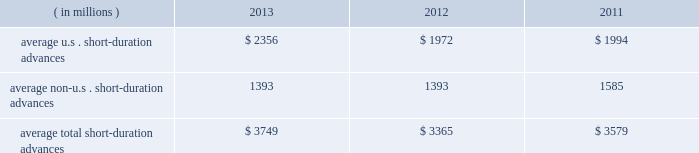Management 2019s discussion and analysis of financial condition and results of operations ( continued ) the table presents average u.s .
And non-u.s .
Short-duration advances for the years ended december 31 : years ended december 31 .
Although average short-duration advances for the year ended december 31 , 2013 increased compared to the year ended december 31 , 2012 , such average advances remained low relative to historical levels , mainly the result of clients continuing to hold higher levels of liquidity .
Average other interest-earning assets increased to $ 11.16 billion for the year ended december 31 , 2013 from $ 7.38 billion for the year ended december 31 , 2012 .
The increased levels were primarily the result of higher levels of cash collateral provided in connection with our participation in principal securities finance transactions .
Aggregate average interest-bearing deposits increased to $ 109.25 billion for the year ended december 31 , 2013 from $ 98.39 billion for the year ended december 31 , 2012 .
This increase was mainly due to higher levels of non-u.s .
Transaction accounts associated with the growth of new and existing business in assets under custody and administration .
Future transaction account levels will be influenced by the underlying asset servicing business , as well as market conditions , including the general levels of u.s .
And non-u.s .
Interest rates .
Average other short-term borrowings declined to $ 3.79 billion for the year ended december 31 , 2013 from $ 4.68 billion for the year ended december 31 , 2012 , as higher levels of client deposits provided additional liquidity .
Average long-term debt increased to $ 8.42 billion for the year ended december 31 , 2013 from $ 7.01 billion for the year ended december 31 , 2012 .
The increase primarily reflected the issuance of $ 1.0 billion of extendible notes by state street bank in december 2012 , the issuance of $ 1.5 billion of senior and subordinated debt in may 2013 , and the issuance of $ 1.0 billion of senior debt in november 2013 .
This increase was partly offset by maturities of $ 1.75 billion of senior debt in the second quarter of 2012 .
Average other interest-bearing liabilities increased to $ 6.46 billion for the year ended december 31 , 2013 from $ 5.90 billion for the year ended december 31 , 2012 , primarily the result of higher levels of cash collateral received from clients in connection with our participation in principal securities finance transactions .
Several factors could affect future levels of our net interest revenue and margin , including the mix of client liabilities ; actions of various central banks ; changes in u.s .
And non-u.s .
Interest rates ; changes in the various yield curves around the world ; revised or proposed regulatory capital or liquidity standards , or interpretations of those standards ; the amount of discount accretion generated by the former conduit securities that remain in our investment securities portfolio ; and the yields earned on securities purchased compared to the yields earned on securities sold or matured .
Based on market conditions and other factors , we continue to reinvest the majority of the proceeds from pay- downs and maturities of investment securities in highly-rated securities , such as u.s .
Treasury and agency securities , federal agency mortgage-backed securities and u.s .
And non-u.s .
Mortgage- and asset-backed securities .
The pace at which we continue to reinvest and the types of investment securities purchased will depend on the impact of market conditions and other factors over time .
We expect these factors and the levels of global interest rates to dictate what effect our reinvestment program will have on future levels of our net interest revenue and net interest margin. .
What is the growth rate of the average total short-duration advances from 2012 to 2013? 
Computations: ((3749 - 3365) / 3365)
Answer: 0.11412. 